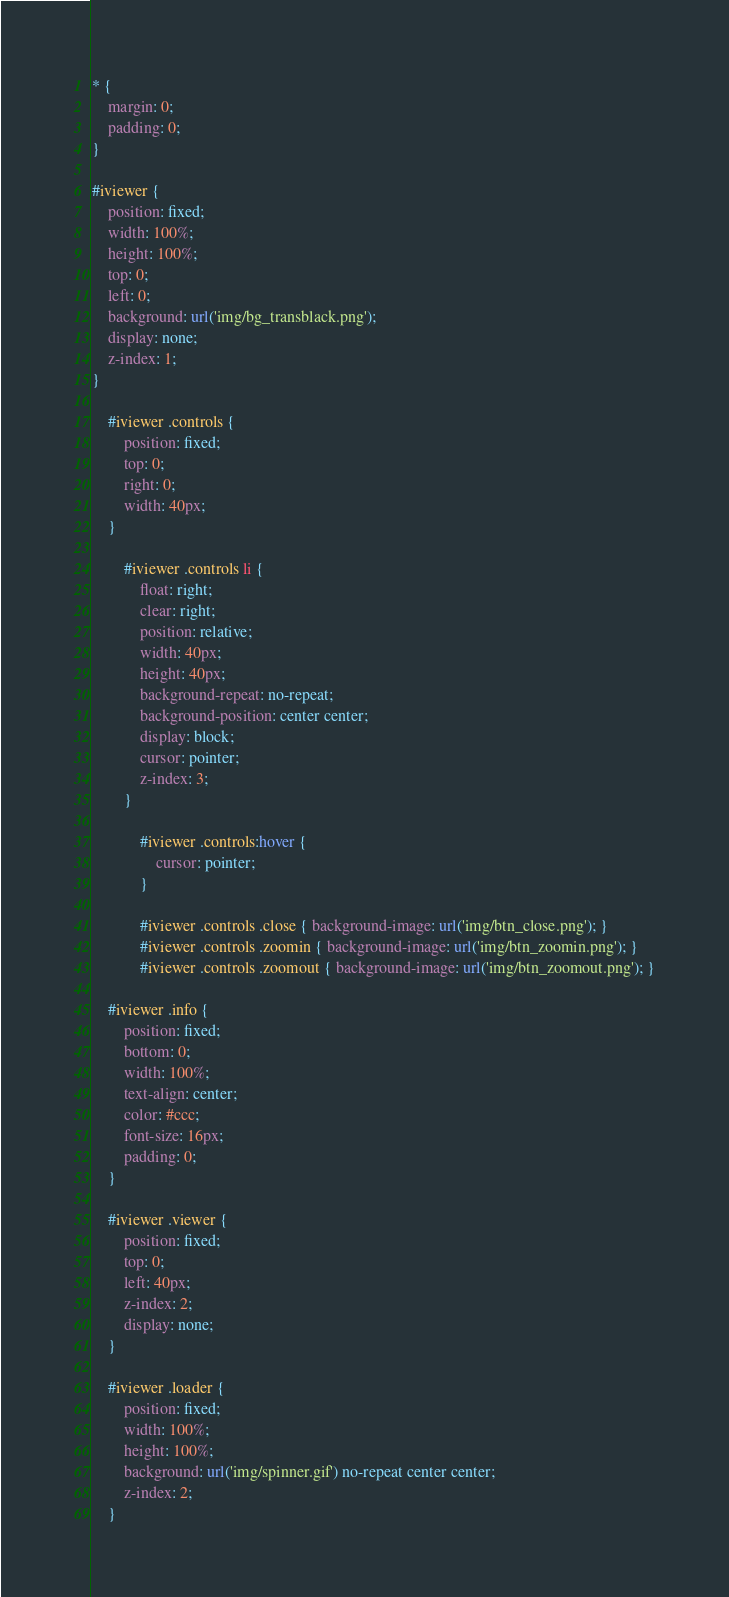<code> <loc_0><loc_0><loc_500><loc_500><_CSS_>* {
	margin: 0;
	padding: 0;
}

#iviewer {
	position: fixed;
	width: 100%;
	height: 100%;
	top: 0;
	left: 0;
	background: url('img/bg_transblack.png');
	display: none;
	z-index: 1;
}

	#iviewer .controls {
		position: fixed;
		top: 0;
		right: 0;
		width: 40px;
	}

		#iviewer .controls li {
			float: right;
			clear: right;
			position: relative;
			width: 40px;
			height: 40px;
			background-repeat: no-repeat;
			background-position: center center;
			display: block;
			cursor: pointer;
			z-index: 3;
		}

			#iviewer .controls:hover {
				cursor: pointer;
			}

			#iviewer .controls .close { background-image: url('img/btn_close.png'); }
			#iviewer .controls .zoomin { background-image: url('img/btn_zoomin.png'); }
			#iviewer .controls .zoomout { background-image: url('img/btn_zoomout.png'); }

	#iviewer .info {
		position: fixed;
		bottom: 0;
		width: 100%;
		text-align: center;
		color: #ccc;
		font-size: 16px;
		padding: 0;
	}

	#iviewer .viewer {
		position: fixed;
		top: 0;
		left: 40px;
		z-index: 2;
		display: none;
	}

	#iviewer .loader {
		position: fixed;
		width: 100%;
		height: 100%;
		background: url('img/spinner.gif') no-repeat center center;
		z-index: 2;
	}</code> 